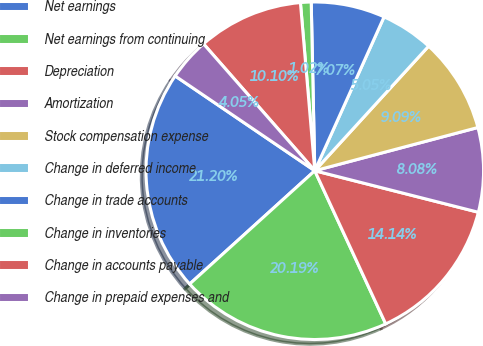Convert chart. <chart><loc_0><loc_0><loc_500><loc_500><pie_chart><fcel>Net earnings<fcel>Net earnings from continuing<fcel>Depreciation<fcel>Amortization<fcel>Stock compensation expense<fcel>Change in deferred income<fcel>Change in trade accounts<fcel>Change in inventories<fcel>Change in accounts payable<fcel>Change in prepaid expenses and<nl><fcel>21.2%<fcel>20.19%<fcel>14.14%<fcel>8.08%<fcel>9.09%<fcel>5.05%<fcel>7.07%<fcel>1.02%<fcel>10.1%<fcel>4.05%<nl></chart> 